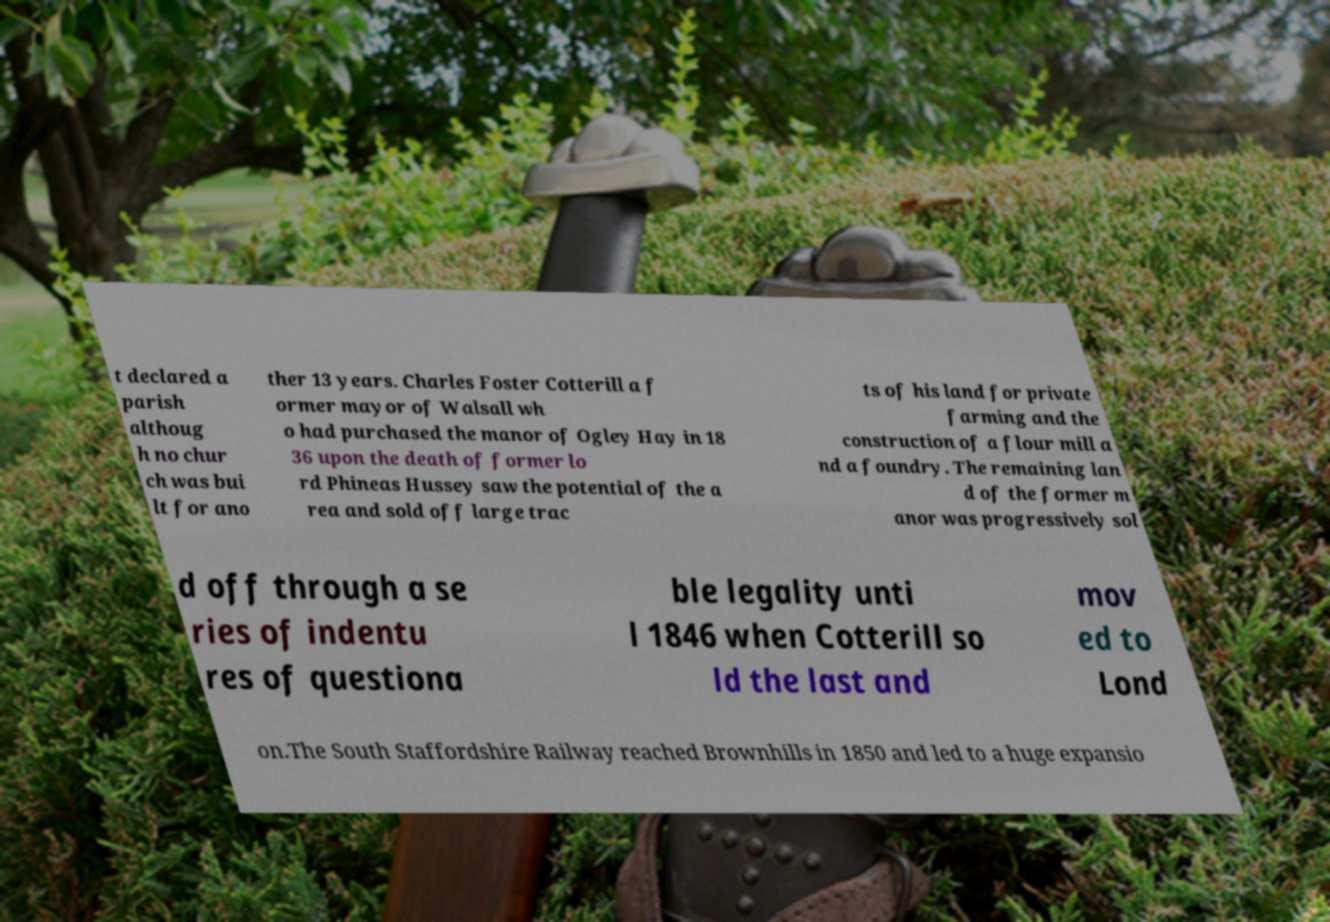There's text embedded in this image that I need extracted. Can you transcribe it verbatim? t declared a parish althoug h no chur ch was bui lt for ano ther 13 years. Charles Foster Cotterill a f ormer mayor of Walsall wh o had purchased the manor of Ogley Hay in 18 36 upon the death of former lo rd Phineas Hussey saw the potential of the a rea and sold off large trac ts of his land for private farming and the construction of a flour mill a nd a foundry. The remaining lan d of the former m anor was progressively sol d off through a se ries of indentu res of questiona ble legality unti l 1846 when Cotterill so ld the last and mov ed to Lond on.The South Staffordshire Railway reached Brownhills in 1850 and led to a huge expansio 